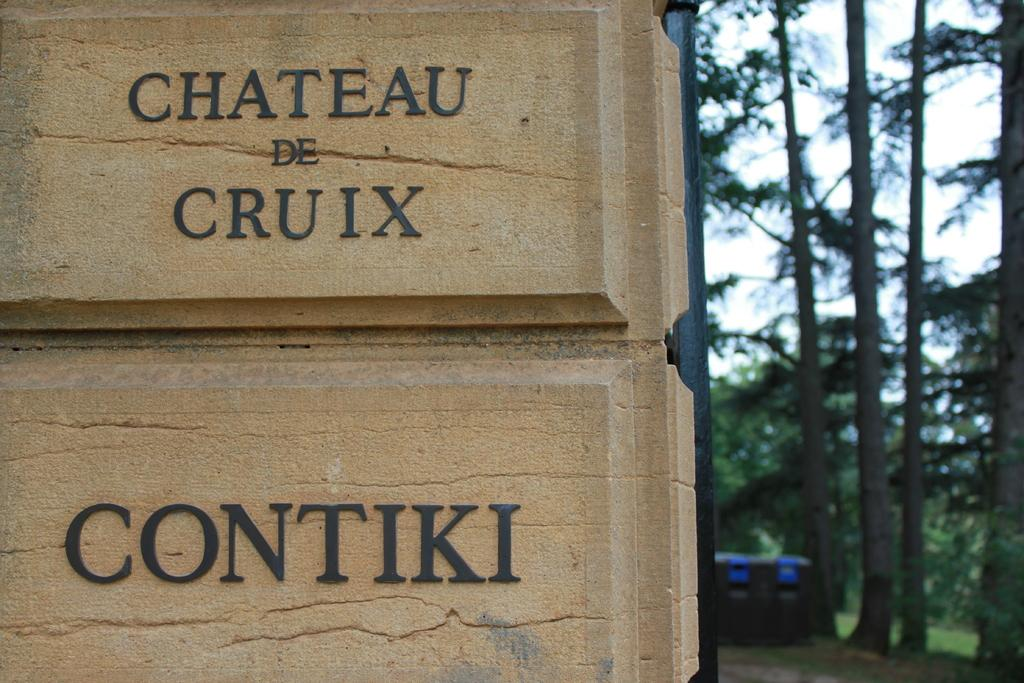What is on the left side of the image? There is a wall with names on the left side of the image. What can be seen on the right side of the image? There are trees on the right side of the image. Can you hear the bats flying around in the image? There are no bats present in the image, so it is not possible to hear them. 